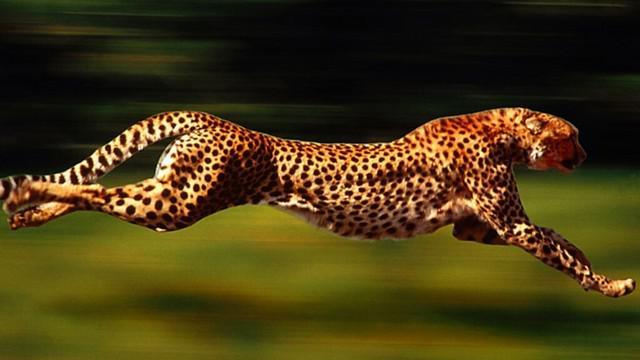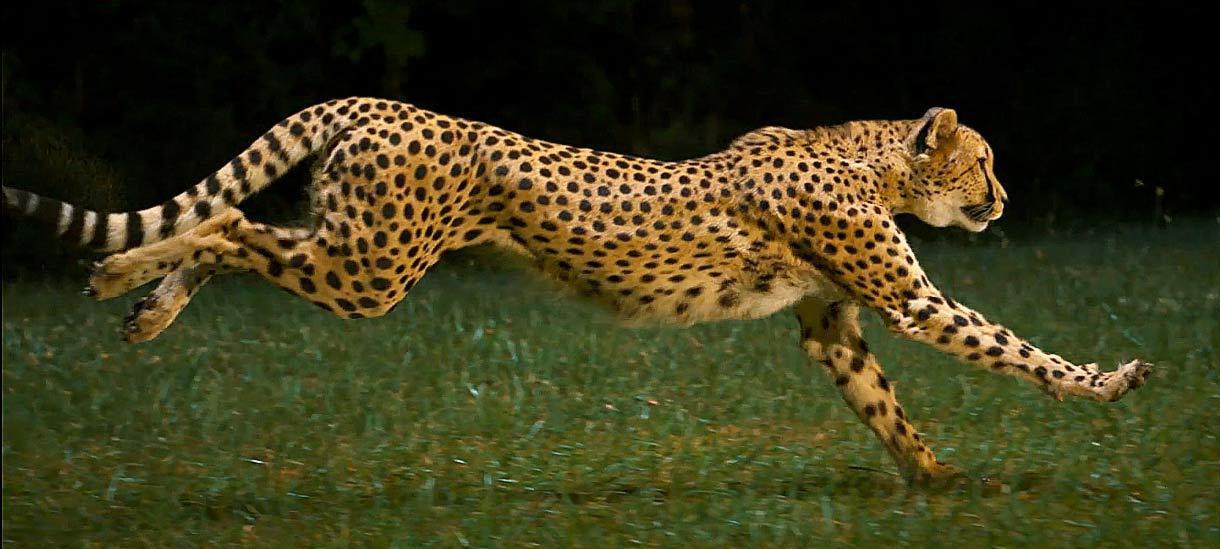The first image is the image on the left, the second image is the image on the right. Assess this claim about the two images: "All the cheetahs are running the same direction, to the right.". Correct or not? Answer yes or no. Yes. 